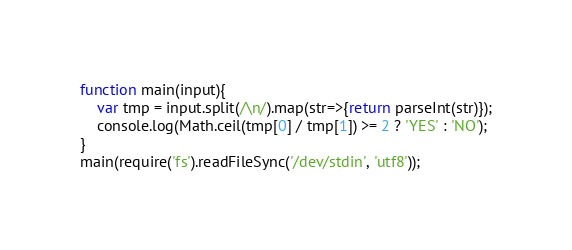Convert code to text. <code><loc_0><loc_0><loc_500><loc_500><_JavaScript_>function main(input){
    var tmp = input.split(/\n/).map(str=>{return parseInt(str)});
    console.log(Math.ceil(tmp[0] / tmp[1]) >= 2 ? 'YES' : 'NO');
}
main(require('fs').readFileSync('/dev/stdin', 'utf8'));</code> 